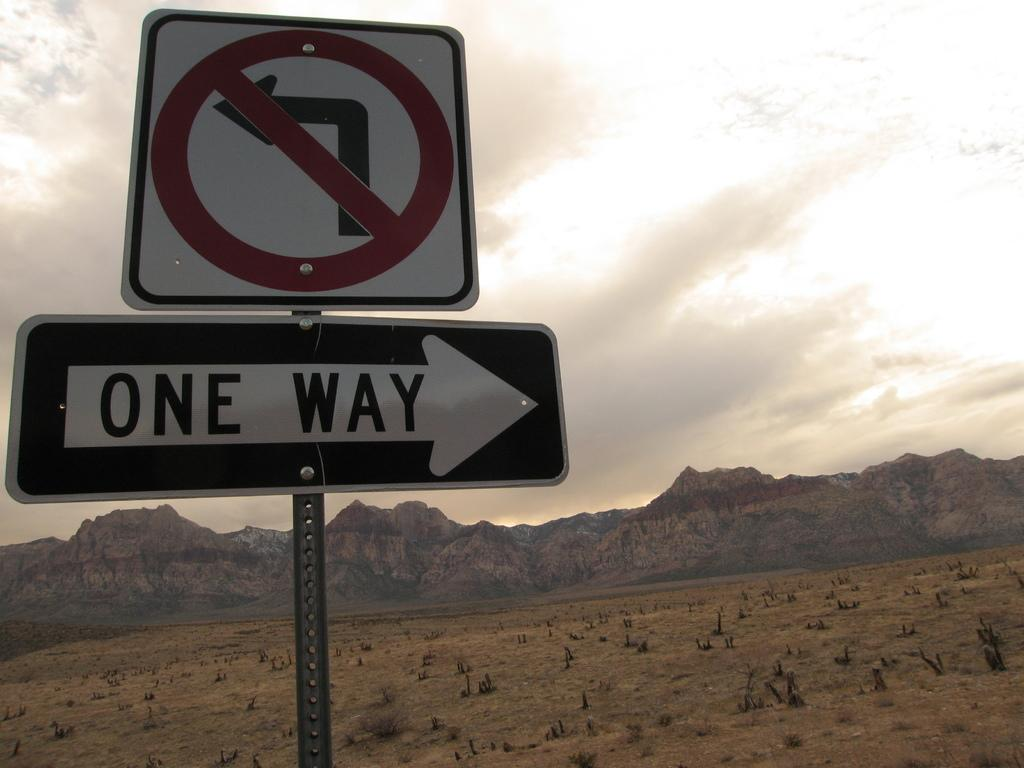Provide a one-sentence caption for the provided image. A black and white road sign indicates that a certain road goes only one way. 